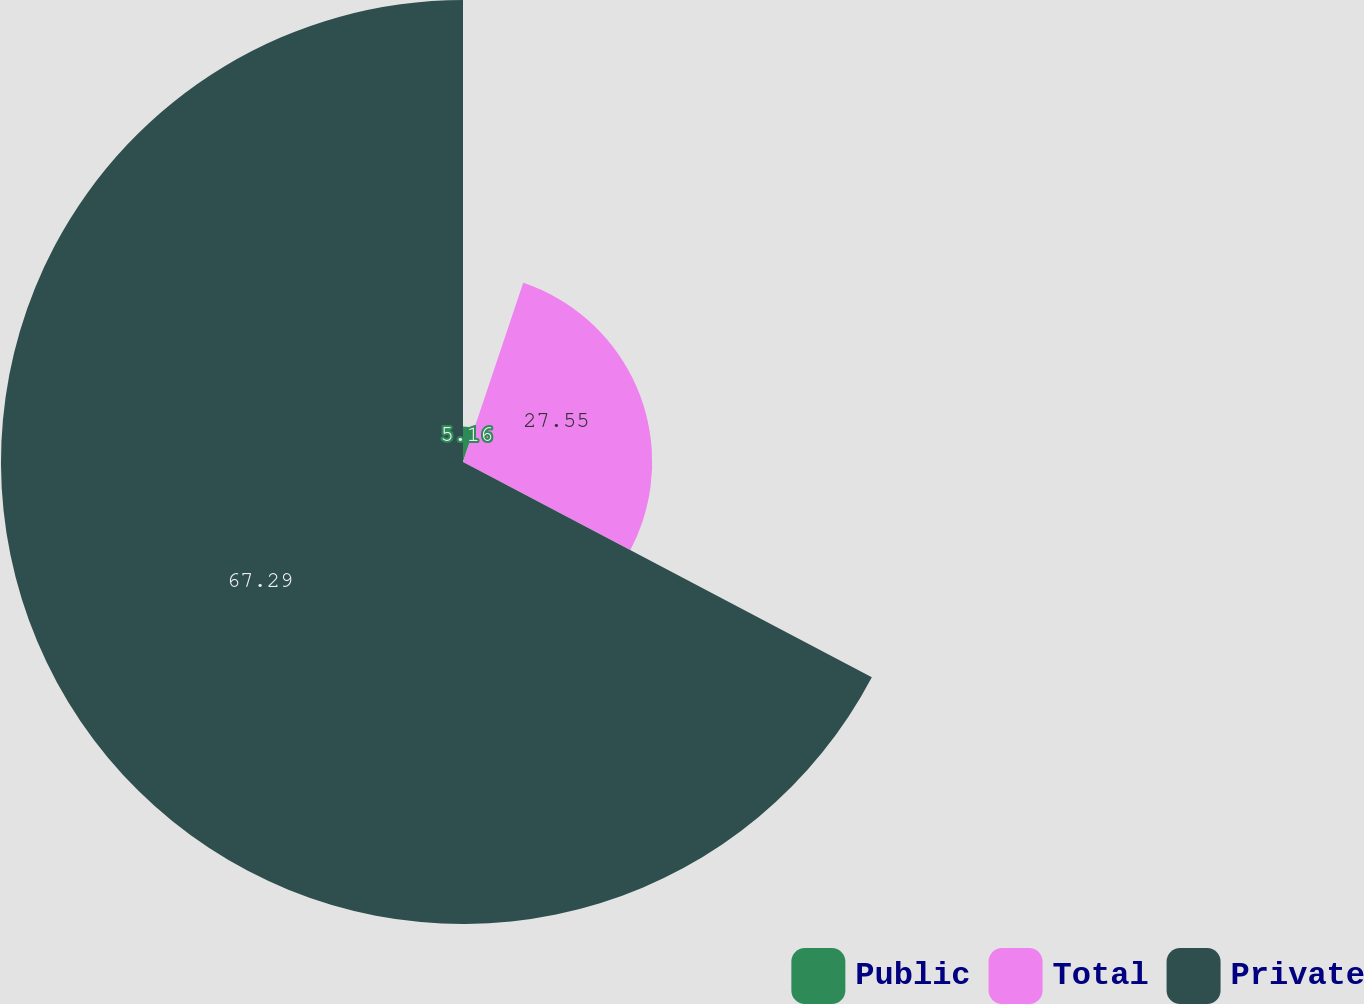Convert chart to OTSL. <chart><loc_0><loc_0><loc_500><loc_500><pie_chart><fcel>Public<fcel>Total<fcel>Private<nl><fcel>5.16%<fcel>27.55%<fcel>67.29%<nl></chart> 